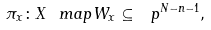Convert formula to latex. <formula><loc_0><loc_0><loc_500><loc_500>\pi _ { x } \colon X \ m a p W _ { x } \subseteq \ p ^ { N - n - 1 } ,</formula> 